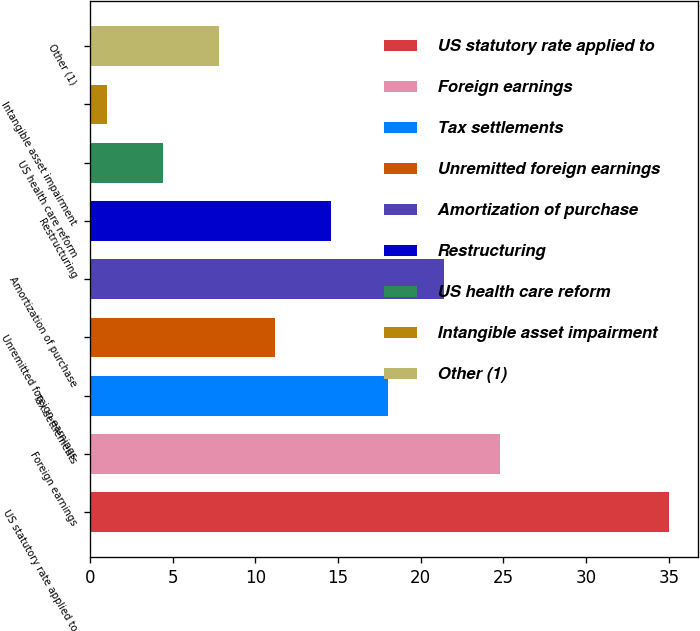Convert chart to OTSL. <chart><loc_0><loc_0><loc_500><loc_500><bar_chart><fcel>US statutory rate applied to<fcel>Foreign earnings<fcel>Tax settlements<fcel>Unremitted foreign earnings<fcel>Amortization of purchase<fcel>Restructuring<fcel>US health care reform<fcel>Intangible asset impairment<fcel>Other (1)<nl><fcel>35<fcel>24.8<fcel>18<fcel>11.2<fcel>21.4<fcel>14.6<fcel>4.4<fcel>1<fcel>7.8<nl></chart> 